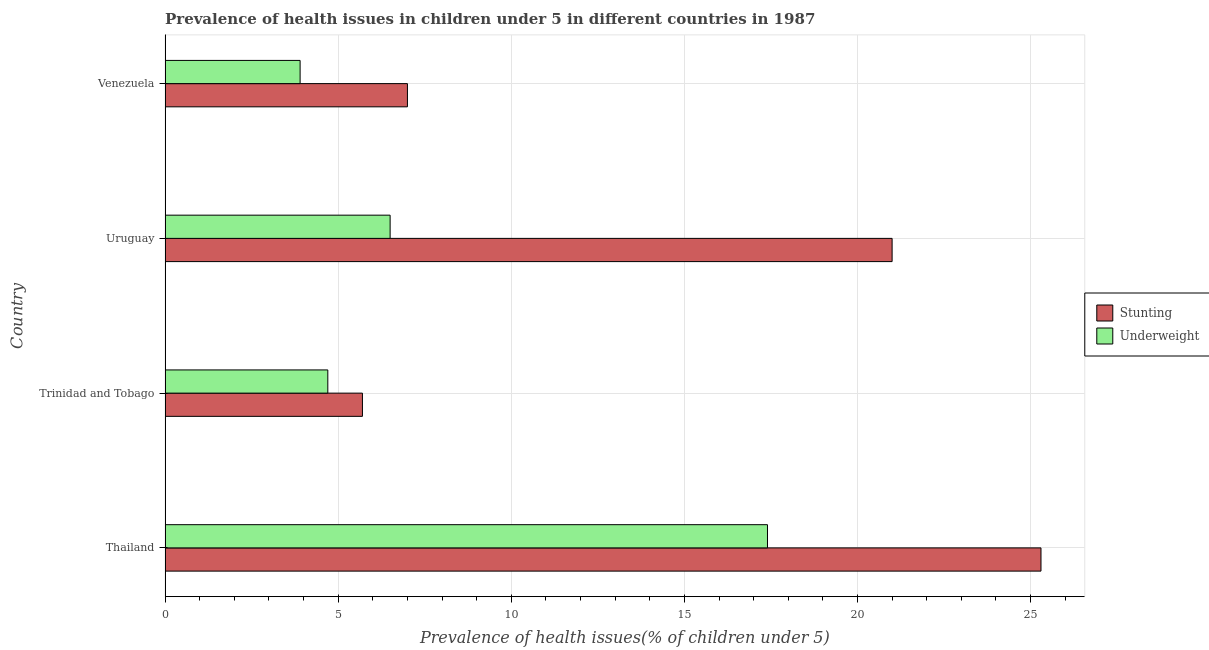Are the number of bars per tick equal to the number of legend labels?
Provide a short and direct response. Yes. How many bars are there on the 4th tick from the bottom?
Your response must be concise. 2. What is the label of the 1st group of bars from the top?
Give a very brief answer. Venezuela. In how many cases, is the number of bars for a given country not equal to the number of legend labels?
Give a very brief answer. 0. What is the percentage of underweight children in Venezuela?
Your response must be concise. 3.9. Across all countries, what is the maximum percentage of underweight children?
Provide a short and direct response. 17.4. Across all countries, what is the minimum percentage of underweight children?
Provide a succinct answer. 3.9. In which country was the percentage of stunted children maximum?
Offer a very short reply. Thailand. In which country was the percentage of stunted children minimum?
Keep it short and to the point. Trinidad and Tobago. What is the total percentage of underweight children in the graph?
Give a very brief answer. 32.5. What is the difference between the percentage of stunted children in Thailand and that in Trinidad and Tobago?
Keep it short and to the point. 19.6. What is the difference between the percentage of stunted children in Uruguay and the percentage of underweight children in Trinidad and Tobago?
Give a very brief answer. 16.3. What is the average percentage of stunted children per country?
Ensure brevity in your answer.  14.75. In how many countries, is the percentage of underweight children greater than 12 %?
Ensure brevity in your answer.  1. What is the ratio of the percentage of underweight children in Uruguay to that in Venezuela?
Your response must be concise. 1.67. Is the percentage of stunted children in Thailand less than that in Venezuela?
Keep it short and to the point. No. In how many countries, is the percentage of underweight children greater than the average percentage of underweight children taken over all countries?
Give a very brief answer. 1. Is the sum of the percentage of stunted children in Trinidad and Tobago and Venezuela greater than the maximum percentage of underweight children across all countries?
Offer a terse response. No. What does the 2nd bar from the top in Thailand represents?
Ensure brevity in your answer.  Stunting. What does the 1st bar from the bottom in Trinidad and Tobago represents?
Provide a succinct answer. Stunting. How many bars are there?
Offer a very short reply. 8. Are all the bars in the graph horizontal?
Provide a succinct answer. Yes. How many countries are there in the graph?
Offer a terse response. 4. Where does the legend appear in the graph?
Your response must be concise. Center right. What is the title of the graph?
Offer a terse response. Prevalence of health issues in children under 5 in different countries in 1987. What is the label or title of the X-axis?
Give a very brief answer. Prevalence of health issues(% of children under 5). What is the label or title of the Y-axis?
Keep it short and to the point. Country. What is the Prevalence of health issues(% of children under 5) in Stunting in Thailand?
Offer a terse response. 25.3. What is the Prevalence of health issues(% of children under 5) in Underweight in Thailand?
Ensure brevity in your answer.  17.4. What is the Prevalence of health issues(% of children under 5) in Stunting in Trinidad and Tobago?
Offer a very short reply. 5.7. What is the Prevalence of health issues(% of children under 5) of Underweight in Trinidad and Tobago?
Provide a succinct answer. 4.7. What is the Prevalence of health issues(% of children under 5) in Stunting in Uruguay?
Your response must be concise. 21. What is the Prevalence of health issues(% of children under 5) in Stunting in Venezuela?
Your response must be concise. 7. What is the Prevalence of health issues(% of children under 5) of Underweight in Venezuela?
Your response must be concise. 3.9. Across all countries, what is the maximum Prevalence of health issues(% of children under 5) of Stunting?
Give a very brief answer. 25.3. Across all countries, what is the maximum Prevalence of health issues(% of children under 5) of Underweight?
Your response must be concise. 17.4. Across all countries, what is the minimum Prevalence of health issues(% of children under 5) in Stunting?
Provide a succinct answer. 5.7. Across all countries, what is the minimum Prevalence of health issues(% of children under 5) of Underweight?
Make the answer very short. 3.9. What is the total Prevalence of health issues(% of children under 5) in Stunting in the graph?
Make the answer very short. 59. What is the total Prevalence of health issues(% of children under 5) in Underweight in the graph?
Offer a very short reply. 32.5. What is the difference between the Prevalence of health issues(% of children under 5) of Stunting in Thailand and that in Trinidad and Tobago?
Offer a very short reply. 19.6. What is the difference between the Prevalence of health issues(% of children under 5) in Underweight in Thailand and that in Trinidad and Tobago?
Keep it short and to the point. 12.7. What is the difference between the Prevalence of health issues(% of children under 5) in Stunting in Thailand and that in Venezuela?
Provide a succinct answer. 18.3. What is the difference between the Prevalence of health issues(% of children under 5) in Underweight in Thailand and that in Venezuela?
Offer a very short reply. 13.5. What is the difference between the Prevalence of health issues(% of children under 5) of Stunting in Trinidad and Tobago and that in Uruguay?
Provide a short and direct response. -15.3. What is the difference between the Prevalence of health issues(% of children under 5) in Stunting in Trinidad and Tobago and that in Venezuela?
Your answer should be very brief. -1.3. What is the difference between the Prevalence of health issues(% of children under 5) of Stunting in Thailand and the Prevalence of health issues(% of children under 5) of Underweight in Trinidad and Tobago?
Make the answer very short. 20.6. What is the difference between the Prevalence of health issues(% of children under 5) in Stunting in Thailand and the Prevalence of health issues(% of children under 5) in Underweight in Venezuela?
Offer a terse response. 21.4. What is the difference between the Prevalence of health issues(% of children under 5) of Stunting in Trinidad and Tobago and the Prevalence of health issues(% of children under 5) of Underweight in Uruguay?
Ensure brevity in your answer.  -0.8. What is the difference between the Prevalence of health issues(% of children under 5) of Stunting in Trinidad and Tobago and the Prevalence of health issues(% of children under 5) of Underweight in Venezuela?
Your response must be concise. 1.8. What is the average Prevalence of health issues(% of children under 5) in Stunting per country?
Offer a very short reply. 14.75. What is the average Prevalence of health issues(% of children under 5) of Underweight per country?
Your answer should be compact. 8.12. What is the difference between the Prevalence of health issues(% of children under 5) of Stunting and Prevalence of health issues(% of children under 5) of Underweight in Thailand?
Your answer should be very brief. 7.9. What is the difference between the Prevalence of health issues(% of children under 5) of Stunting and Prevalence of health issues(% of children under 5) of Underweight in Venezuela?
Keep it short and to the point. 3.1. What is the ratio of the Prevalence of health issues(% of children under 5) in Stunting in Thailand to that in Trinidad and Tobago?
Your answer should be very brief. 4.44. What is the ratio of the Prevalence of health issues(% of children under 5) of Underweight in Thailand to that in Trinidad and Tobago?
Give a very brief answer. 3.7. What is the ratio of the Prevalence of health issues(% of children under 5) of Stunting in Thailand to that in Uruguay?
Make the answer very short. 1.2. What is the ratio of the Prevalence of health issues(% of children under 5) in Underweight in Thailand to that in Uruguay?
Offer a very short reply. 2.68. What is the ratio of the Prevalence of health issues(% of children under 5) of Stunting in Thailand to that in Venezuela?
Offer a terse response. 3.61. What is the ratio of the Prevalence of health issues(% of children under 5) of Underweight in Thailand to that in Venezuela?
Offer a very short reply. 4.46. What is the ratio of the Prevalence of health issues(% of children under 5) of Stunting in Trinidad and Tobago to that in Uruguay?
Your answer should be compact. 0.27. What is the ratio of the Prevalence of health issues(% of children under 5) of Underweight in Trinidad and Tobago to that in Uruguay?
Your answer should be very brief. 0.72. What is the ratio of the Prevalence of health issues(% of children under 5) of Stunting in Trinidad and Tobago to that in Venezuela?
Provide a short and direct response. 0.81. What is the ratio of the Prevalence of health issues(% of children under 5) in Underweight in Trinidad and Tobago to that in Venezuela?
Offer a very short reply. 1.21. What is the ratio of the Prevalence of health issues(% of children under 5) in Underweight in Uruguay to that in Venezuela?
Your answer should be very brief. 1.67. What is the difference between the highest and the lowest Prevalence of health issues(% of children under 5) of Stunting?
Provide a succinct answer. 19.6. What is the difference between the highest and the lowest Prevalence of health issues(% of children under 5) of Underweight?
Your answer should be compact. 13.5. 